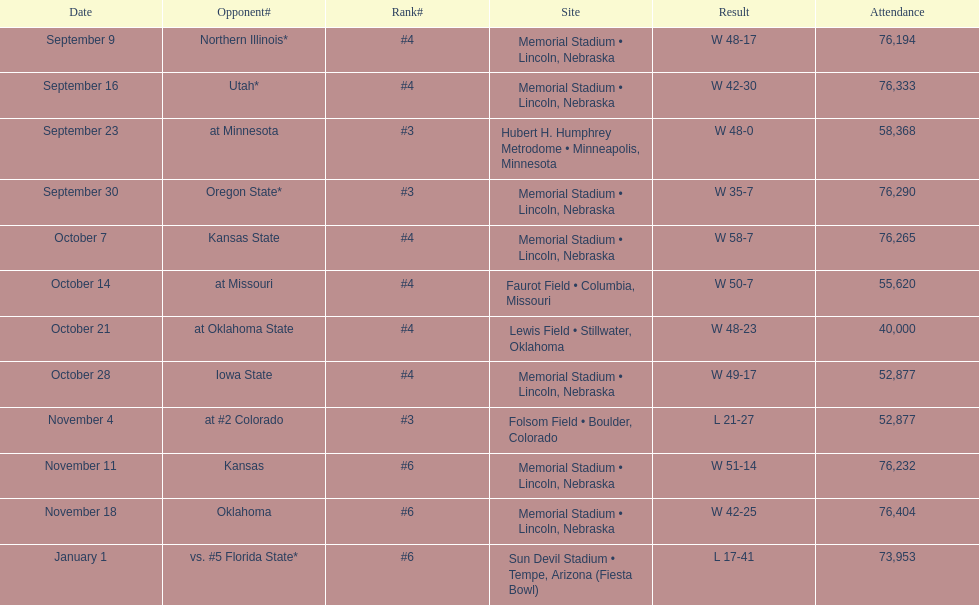Can you give me this table as a dict? {'header': ['Date', 'Opponent#', 'Rank#', 'Site', 'Result', 'Attendance'], 'rows': [['September 9', 'Northern Illinois*', '#4', 'Memorial Stadium • Lincoln, Nebraska', 'W\xa048-17', '76,194'], ['September 16', 'Utah*', '#4', 'Memorial Stadium • Lincoln, Nebraska', 'W\xa042-30', '76,333'], ['September 23', 'at\xa0Minnesota', '#3', 'Hubert H. Humphrey Metrodome • Minneapolis, Minnesota', 'W\xa048-0', '58,368'], ['September 30', 'Oregon State*', '#3', 'Memorial Stadium • Lincoln, Nebraska', 'W\xa035-7', '76,290'], ['October 7', 'Kansas State', '#4', 'Memorial Stadium • Lincoln, Nebraska', 'W\xa058-7', '76,265'], ['October 14', 'at\xa0Missouri', '#4', 'Faurot Field • Columbia, Missouri', 'W\xa050-7', '55,620'], ['October 21', 'at\xa0Oklahoma State', '#4', 'Lewis Field • Stillwater, Oklahoma', 'W\xa048-23', '40,000'], ['October 28', 'Iowa State', '#4', 'Memorial Stadium • Lincoln, Nebraska', 'W\xa049-17', '52,877'], ['November 4', 'at\xa0#2\xa0Colorado', '#3', 'Folsom Field • Boulder, Colorado', 'L\xa021-27', '52,877'], ['November 11', 'Kansas', '#6', 'Memorial Stadium • Lincoln, Nebraska', 'W\xa051-14', '76,232'], ['November 18', 'Oklahoma', '#6', 'Memorial Stadium • Lincoln, Nebraska', 'W\xa042-25', '76,404'], ['January 1', 'vs.\xa0#5\xa0Florida State*', '#6', 'Sun Devil Stadium • Tempe, Arizona (Fiesta Bowl)', 'L\xa017-41', '73,953']]} Which month is listed the least on this chart? January. 